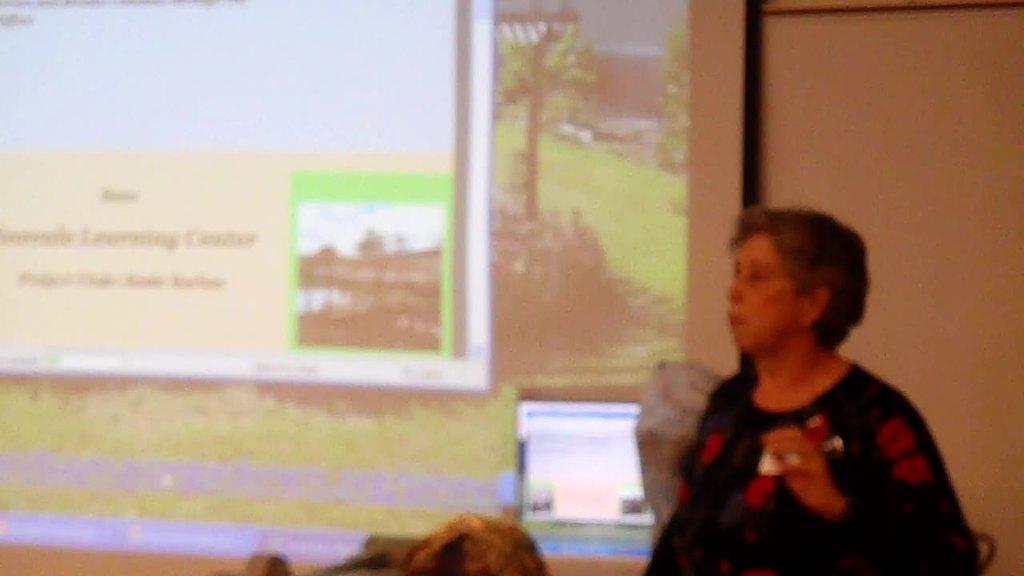How would you summarize this image in a sentence or two? In the image on the right side there is a lady. On the left side of the image there is a screen with images. 